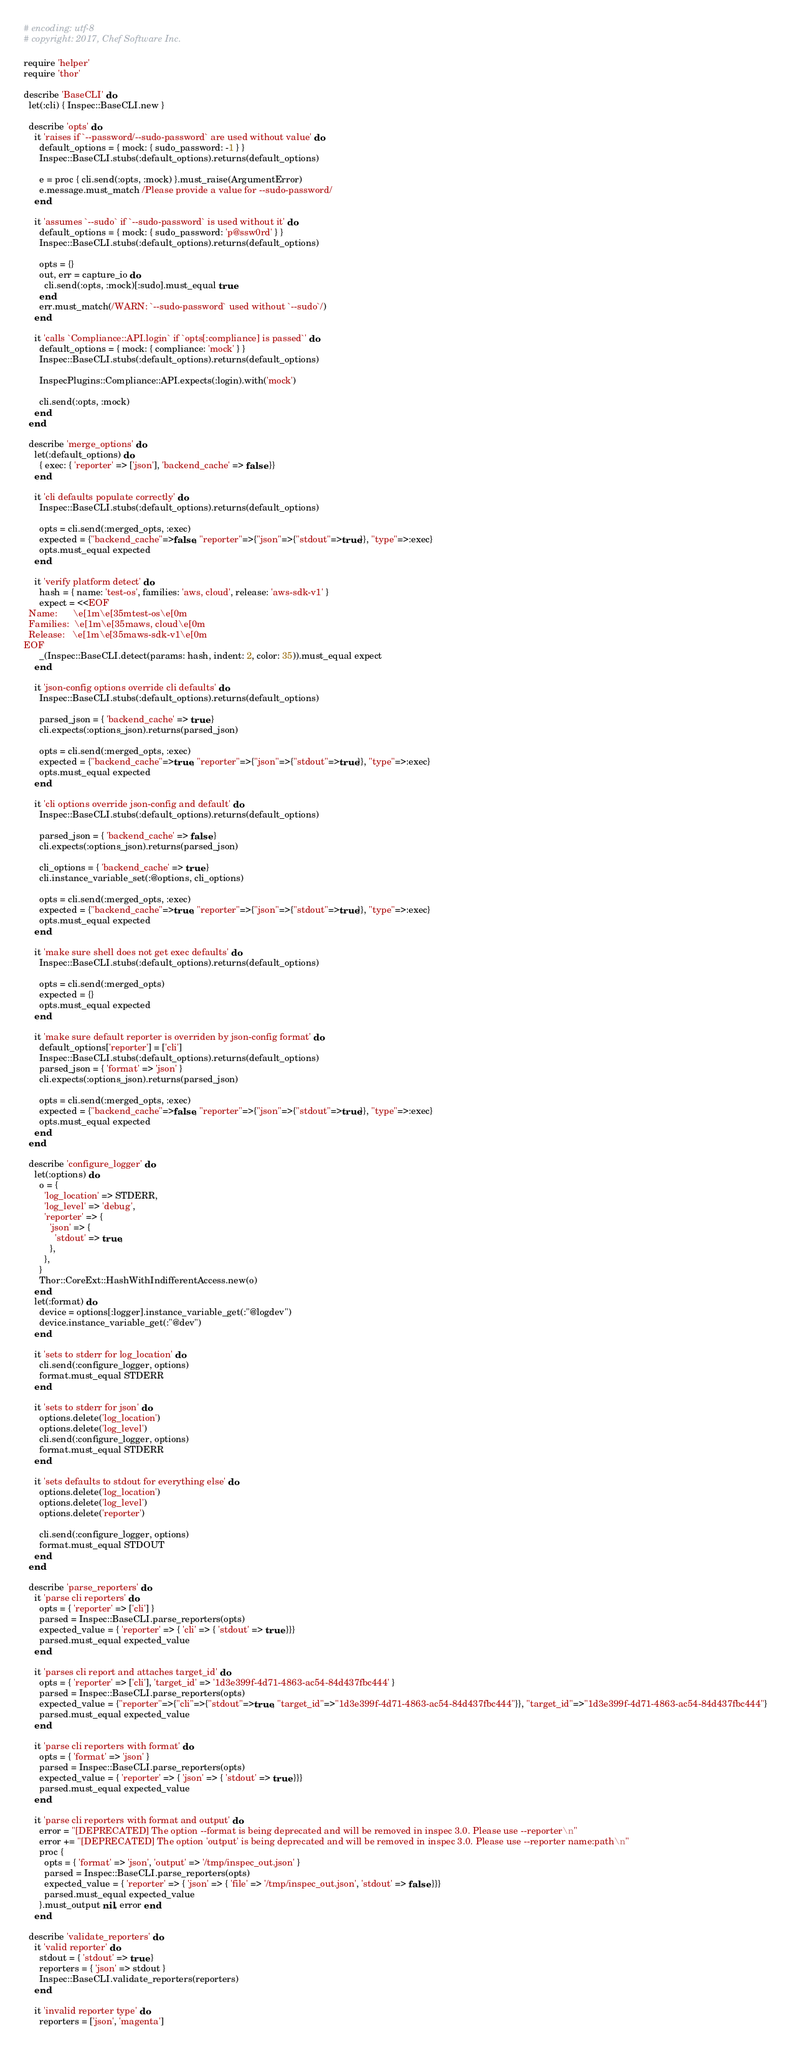Convert code to text. <code><loc_0><loc_0><loc_500><loc_500><_Ruby_># encoding: utf-8
# copyright: 2017, Chef Software Inc.

require 'helper'
require 'thor'

describe 'BaseCLI' do
  let(:cli) { Inspec::BaseCLI.new }

  describe 'opts' do
    it 'raises if `--password/--sudo-password` are used without value' do
      default_options = { mock: { sudo_password: -1 } }
      Inspec::BaseCLI.stubs(:default_options).returns(default_options)

      e = proc { cli.send(:opts, :mock) }.must_raise(ArgumentError)
      e.message.must_match /Please provide a value for --sudo-password/
    end

    it 'assumes `--sudo` if `--sudo-password` is used without it' do
      default_options = { mock: { sudo_password: 'p@ssw0rd' } }
      Inspec::BaseCLI.stubs(:default_options).returns(default_options)

      opts = {}
      out, err = capture_io do
        cli.send(:opts, :mock)[:sudo].must_equal true
      end
      err.must_match(/WARN: `--sudo-password` used without `--sudo`/)
    end

    it 'calls `Compliance::API.login` if `opts[:compliance] is passed`' do
      default_options = { mock: { compliance: 'mock' } }
      Inspec::BaseCLI.stubs(:default_options).returns(default_options)

      InspecPlugins::Compliance::API.expects(:login).with('mock')

      cli.send(:opts, :mock)
    end
  end

  describe 'merge_options' do
    let(:default_options) do
      { exec: { 'reporter' => ['json'], 'backend_cache' => false }}
    end

    it 'cli defaults populate correctly' do
      Inspec::BaseCLI.stubs(:default_options).returns(default_options)

      opts = cli.send(:merged_opts, :exec)
      expected = {"backend_cache"=>false, "reporter"=>{"json"=>{"stdout"=>true}}, "type"=>:exec}
      opts.must_equal expected
    end

    it 'verify platform detect' do
      hash = { name: 'test-os', families: 'aws, cloud', release: 'aws-sdk-v1' }
      expect = <<EOF
  Name:      \e[1m\e[35mtest-os\e[0m
  Families:  \e[1m\e[35maws, cloud\e[0m
  Release:   \e[1m\e[35maws-sdk-v1\e[0m
EOF
      _(Inspec::BaseCLI.detect(params: hash, indent: 2, color: 35)).must_equal expect
    end

    it 'json-config options override cli defaults' do
      Inspec::BaseCLI.stubs(:default_options).returns(default_options)

      parsed_json = { 'backend_cache' => true }
      cli.expects(:options_json).returns(parsed_json)

      opts = cli.send(:merged_opts, :exec)
      expected = {"backend_cache"=>true, "reporter"=>{"json"=>{"stdout"=>true}}, "type"=>:exec}
      opts.must_equal expected
    end

    it 'cli options override json-config and default' do
      Inspec::BaseCLI.stubs(:default_options).returns(default_options)

      parsed_json = { 'backend_cache' => false }
      cli.expects(:options_json).returns(parsed_json)

      cli_options = { 'backend_cache' => true }
      cli.instance_variable_set(:@options, cli_options)

      opts = cli.send(:merged_opts, :exec)
      expected = {"backend_cache"=>true, "reporter"=>{"json"=>{"stdout"=>true}}, "type"=>:exec}
      opts.must_equal expected
    end

    it 'make sure shell does not get exec defaults' do
      Inspec::BaseCLI.stubs(:default_options).returns(default_options)

      opts = cli.send(:merged_opts)
      expected = {}
      opts.must_equal expected
    end

    it 'make sure default reporter is overriden by json-config format' do
      default_options['reporter'] = ['cli']
      Inspec::BaseCLI.stubs(:default_options).returns(default_options)
      parsed_json = { 'format' => 'json' }
      cli.expects(:options_json).returns(parsed_json)

      opts = cli.send(:merged_opts, :exec)
      expected = {"backend_cache"=>false, "reporter"=>{"json"=>{"stdout"=>true}}, "type"=>:exec}
      opts.must_equal expected
    end
  end

  describe 'configure_logger' do
    let(:options) do
      o = {
        'log_location' => STDERR,
        'log_level' => 'debug',
        'reporter' => {
          'json' => {
            'stdout' => true,
          },
        },
      }
      Thor::CoreExt::HashWithIndifferentAccess.new(o)
    end
    let(:format) do
      device = options[:logger].instance_variable_get(:"@logdev")
      device.instance_variable_get(:"@dev")
    end

    it 'sets to stderr for log_location' do
      cli.send(:configure_logger, options)
      format.must_equal STDERR
    end

    it 'sets to stderr for json' do
      options.delete('log_location')
      options.delete('log_level')
      cli.send(:configure_logger, options)
      format.must_equal STDERR
    end

    it 'sets defaults to stdout for everything else' do
      options.delete('log_location')
      options.delete('log_level')
      options.delete('reporter')

      cli.send(:configure_logger, options)
      format.must_equal STDOUT
    end
  end

  describe 'parse_reporters' do
    it 'parse cli reporters' do
      opts = { 'reporter' => ['cli'] }
      parsed = Inspec::BaseCLI.parse_reporters(opts)
      expected_value = { 'reporter' => { 'cli' => { 'stdout' => true }}}
      parsed.must_equal expected_value
    end

    it 'parses cli report and attaches target_id' do
      opts = { 'reporter' => ['cli'], 'target_id' => '1d3e399f-4d71-4863-ac54-84d437fbc444' }
      parsed = Inspec::BaseCLI.parse_reporters(opts)
      expected_value = {"reporter"=>{"cli"=>{"stdout"=>true, "target_id"=>"1d3e399f-4d71-4863-ac54-84d437fbc444"}}, "target_id"=>"1d3e399f-4d71-4863-ac54-84d437fbc444"}
      parsed.must_equal expected_value
    end

    it 'parse cli reporters with format' do
      opts = { 'format' => 'json' }
      parsed = Inspec::BaseCLI.parse_reporters(opts)
      expected_value = { 'reporter' => { 'json' => { 'stdout' => true }}}
      parsed.must_equal expected_value
    end

    it 'parse cli reporters with format and output' do
      error = "[DEPRECATED] The option --format is being deprecated and will be removed in inspec 3.0. Please use --reporter\n"
      error += "[DEPRECATED] The option 'output' is being deprecated and will be removed in inspec 3.0. Please use --reporter name:path\n"
      proc {
        opts = { 'format' => 'json', 'output' => '/tmp/inspec_out.json' }
        parsed = Inspec::BaseCLI.parse_reporters(opts)
        expected_value = { 'reporter' => { 'json' => { 'file' => '/tmp/inspec_out.json', 'stdout' => false }}}
        parsed.must_equal expected_value
      }.must_output nil, error end
    end

  describe 'validate_reporters' do
    it 'valid reporter' do
      stdout = { 'stdout' => true }
      reporters = { 'json' => stdout }
      Inspec::BaseCLI.validate_reporters(reporters)
    end

    it 'invalid reporter type' do
      reporters = ['json', 'magenta']</code> 